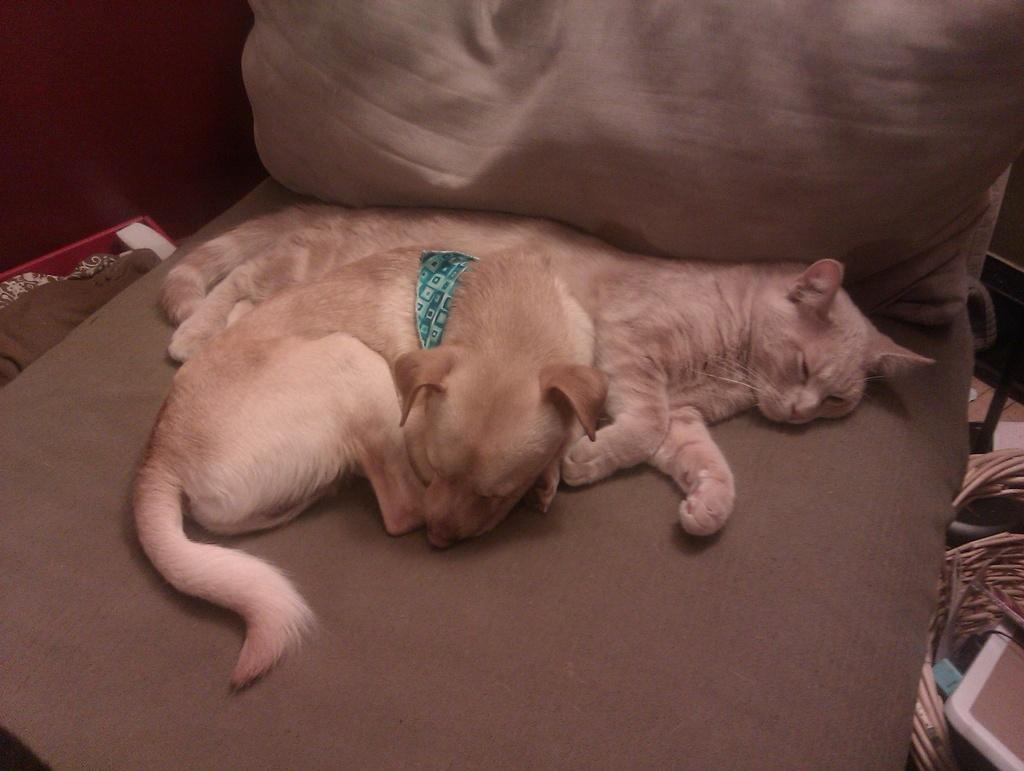What animals can be seen in the image? There is a cat and a dog in the image. Where are the cat and dog located? Both the cat and dog are on a couch. What is visible in the background of the image? There is a wall in the background of the image. What can be seen on the right side of the image? There are objects on the right side of the image. What type of copper material can be seen in the image? There is no copper material present in the image. Can you describe how the bat is being used in the image? There is no bat present in the image. 